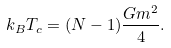<formula> <loc_0><loc_0><loc_500><loc_500>k _ { B } T _ { c } = ( N - 1 ) \frac { G m ^ { 2 } } { 4 } .</formula> 